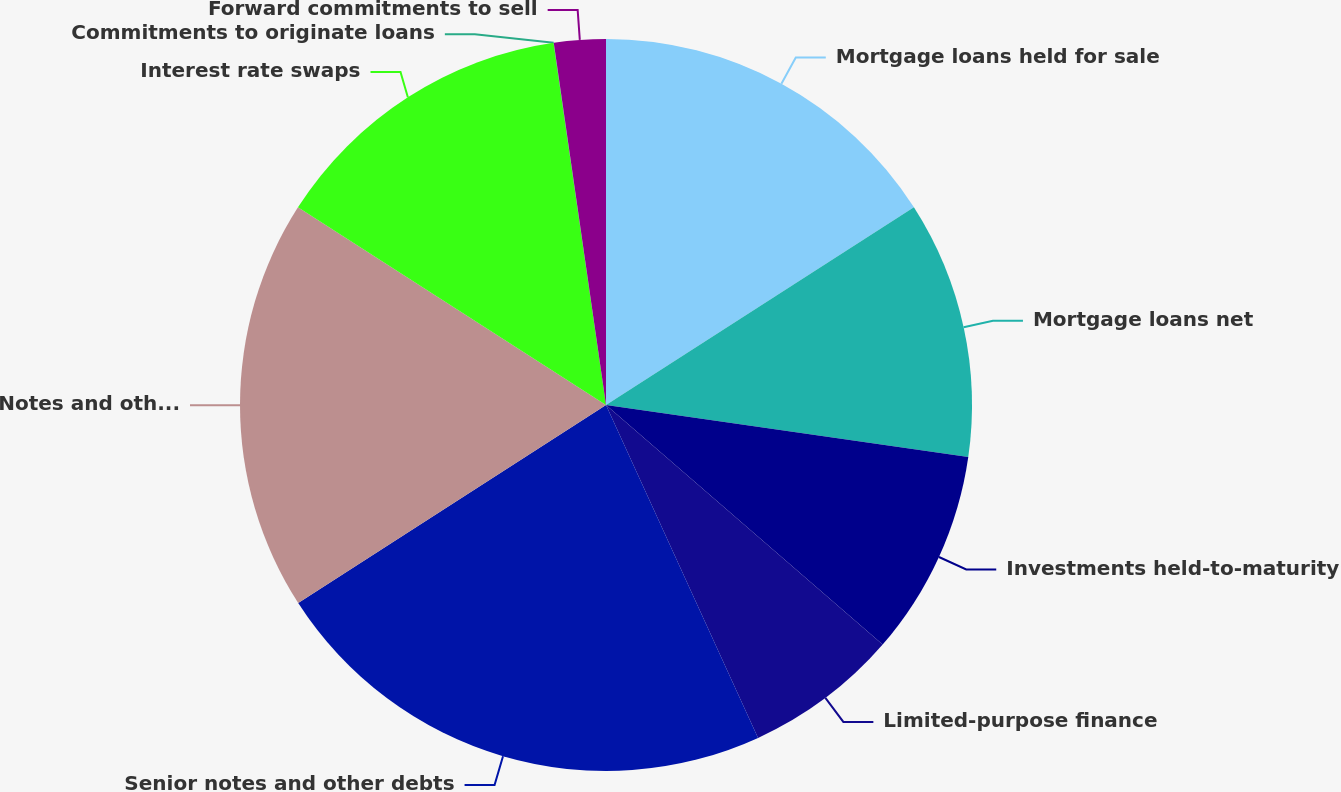Convert chart to OTSL. <chart><loc_0><loc_0><loc_500><loc_500><pie_chart><fcel>Mortgage loans held for sale<fcel>Mortgage loans net<fcel>Investments held-to-maturity<fcel>Limited-purpose finance<fcel>Senior notes and other debts<fcel>Notes and other debts payable<fcel>Interest rate swaps<fcel>Commitments to originate loans<fcel>Forward commitments to sell<nl><fcel>15.91%<fcel>11.36%<fcel>9.09%<fcel>6.82%<fcel>22.72%<fcel>18.18%<fcel>13.63%<fcel>0.01%<fcel>2.28%<nl></chart> 